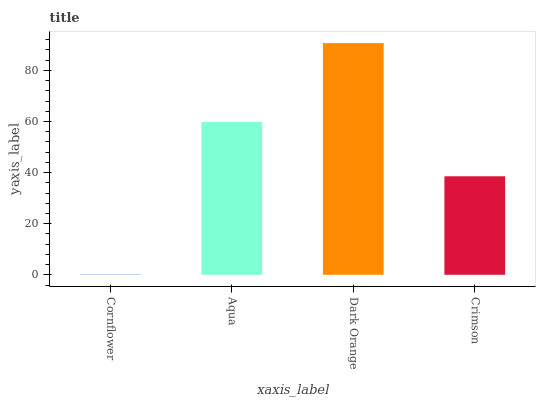Is Cornflower the minimum?
Answer yes or no. Yes. Is Dark Orange the maximum?
Answer yes or no. Yes. Is Aqua the minimum?
Answer yes or no. No. Is Aqua the maximum?
Answer yes or no. No. Is Aqua greater than Cornflower?
Answer yes or no. Yes. Is Cornflower less than Aqua?
Answer yes or no. Yes. Is Cornflower greater than Aqua?
Answer yes or no. No. Is Aqua less than Cornflower?
Answer yes or no. No. Is Aqua the high median?
Answer yes or no. Yes. Is Crimson the low median?
Answer yes or no. Yes. Is Cornflower the high median?
Answer yes or no. No. Is Aqua the low median?
Answer yes or no. No. 